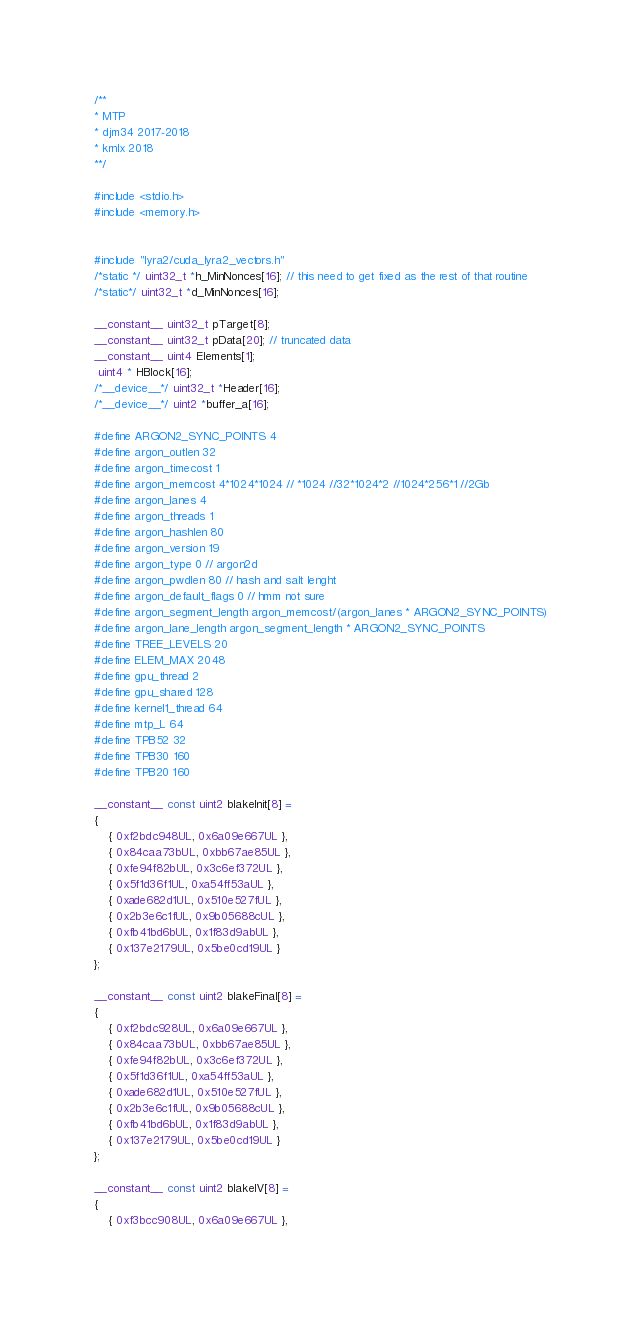Convert code to text. <code><loc_0><loc_0><loc_500><loc_500><_Cuda_>/**
* MTP
* djm34 2017-2018
* krnlx 2018
**/

#include <stdio.h>
#include <memory.h>


#include "lyra2/cuda_lyra2_vectors.h"
/*static */ uint32_t *h_MinNonces[16]; // this need to get fixed as the rest of that routine
/*static*/ uint32_t *d_MinNonces[16];

__constant__ uint32_t pTarget[8];
__constant__ uint32_t pData[20]; // truncated data
__constant__ uint4 Elements[1];
 uint4 * HBlock[16];
/*__device__*/ uint32_t *Header[16];
/*__device__*/ uint2 *buffer_a[16];

#define ARGON2_SYNC_POINTS 4
#define argon_outlen 32
#define argon_timecost 1
#define argon_memcost 4*1024*1024 // *1024 //32*1024*2 //1024*256*1 //2Gb
#define argon_lanes 4
#define argon_threads 1
#define argon_hashlen 80
#define argon_version 19
#define argon_type 0 // argon2d
#define argon_pwdlen 80 // hash and salt lenght
#define argon_default_flags 0 // hmm not sure
#define argon_segment_length argon_memcost/(argon_lanes * ARGON2_SYNC_POINTS)
#define argon_lane_length argon_segment_length * ARGON2_SYNC_POINTS
#define TREE_LEVELS 20
#define ELEM_MAX 2048
#define gpu_thread 2
#define gpu_shared 128
#define kernel1_thread 64
#define mtp_L 64
#define TPB52 32
#define TPB30 160
#define TPB20 160

__constant__ const uint2 blakeInit[8] =
{
	{ 0xf2bdc948UL, 0x6a09e667UL },
	{ 0x84caa73bUL, 0xbb67ae85UL },
	{ 0xfe94f82bUL, 0x3c6ef372UL },
	{ 0x5f1d36f1UL, 0xa54ff53aUL },
	{ 0xade682d1UL, 0x510e527fUL },
	{ 0x2b3e6c1fUL, 0x9b05688cUL },
	{ 0xfb41bd6bUL, 0x1f83d9abUL },
	{ 0x137e2179UL, 0x5be0cd19UL }
};

__constant__ const uint2 blakeFinal[8] =
{
	{ 0xf2bdc928UL, 0x6a09e667UL },
	{ 0x84caa73bUL, 0xbb67ae85UL },
	{ 0xfe94f82bUL, 0x3c6ef372UL },
	{ 0x5f1d36f1UL, 0xa54ff53aUL },
	{ 0xade682d1UL, 0x510e527fUL },
	{ 0x2b3e6c1fUL, 0x9b05688cUL },
	{ 0xfb41bd6bUL, 0x1f83d9abUL },
	{ 0x137e2179UL, 0x5be0cd19UL }
};

__constant__ const uint2 blakeIV[8] =
{
	{ 0xf3bcc908UL, 0x6a09e667UL },</code> 